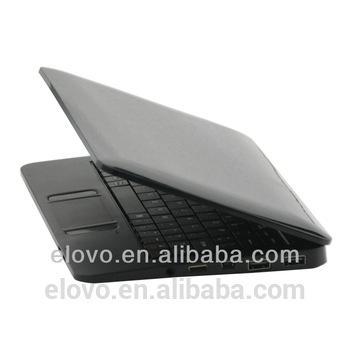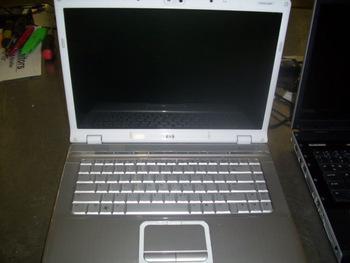The first image is the image on the left, the second image is the image on the right. Assess this claim about the two images: "In one image, laptop computers are lined in rows three across, with at least the first row fully open.". Correct or not? Answer yes or no. No. The first image is the image on the left, the second image is the image on the right. Analyze the images presented: Is the assertion "An image shows rows of lap stocks arranged three across." valid? Answer yes or no. No. 